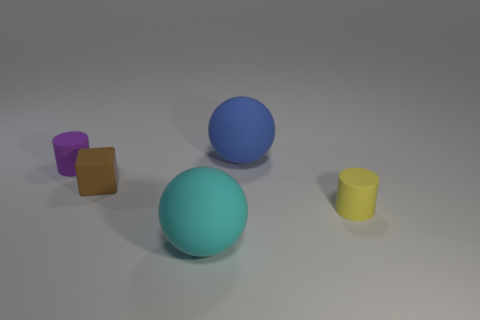There is a large blue thing that is on the right side of the tiny purple cylinder; how many small matte things are on the left side of it?
Provide a short and direct response. 2. How many things are either tiny things that are to the left of the cyan matte thing or tiny brown matte blocks?
Your response must be concise. 2. What number of other small red cubes are the same material as the cube?
Your response must be concise. 0. Are there an equal number of blue rubber spheres in front of the tiny rubber block and big blue things?
Ensure brevity in your answer.  No. How big is the rubber cylinder that is in front of the matte cube?
Your answer should be very brief. Small. What number of small things are either cyan balls or spheres?
Ensure brevity in your answer.  0. What color is the other matte thing that is the same shape as the small yellow object?
Your answer should be very brief. Purple. Is the yellow matte object the same size as the blue rubber ball?
Keep it short and to the point. No. What number of things are gray metallic objects or tiny cylinders to the left of the yellow matte cylinder?
Keep it short and to the point. 1. There is a matte ball that is behind the big rubber object in front of the brown object; what is its color?
Offer a terse response. Blue. 